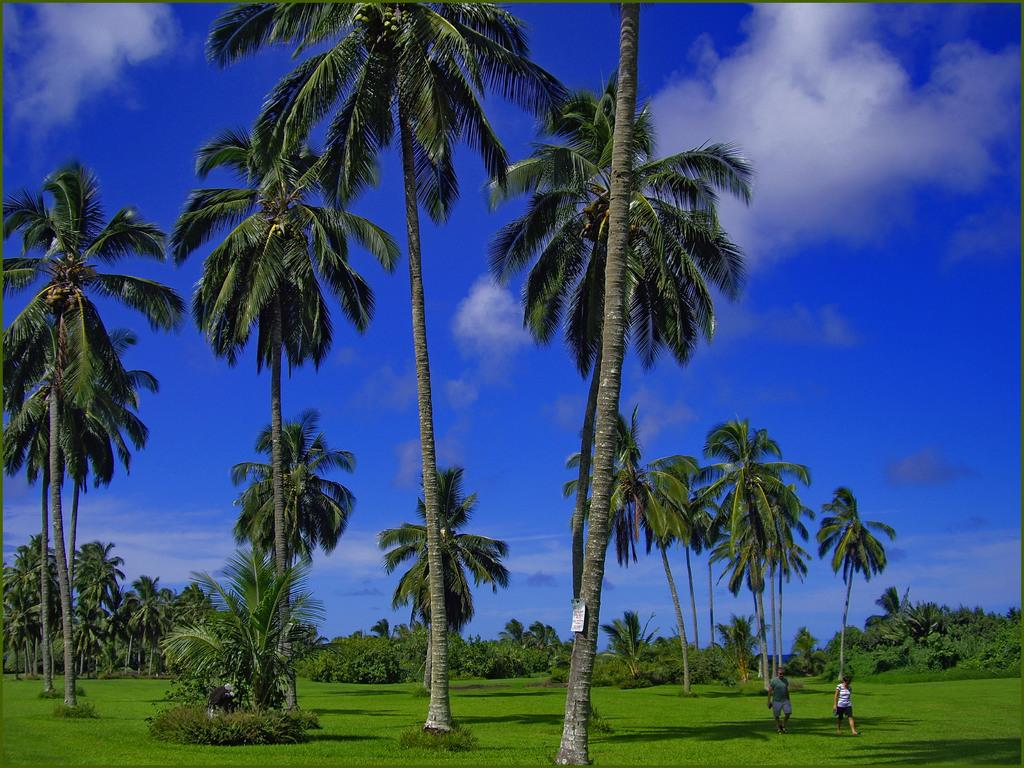What type of vegetation can be seen in the image? There are trees, plants, and grass in the image. What is the primary surface that the two persons are walking on in the image? The two persons are walking on the grass on the right side of the image. What is the background of the image? The sky is visible in the background of the image. What object can be seen in the image that is not related to vegetation? There is a board in the image. What type of oatmeal is being served on the board in the image? There is no oatmeal present in the image, and the board does not appear to be serving any food. How does the tramp interact with the trees in the image? There is no tramp present in the image, and therefore no interaction with the trees can be observed. 